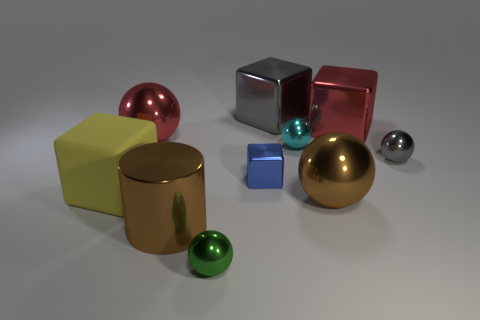Subtract all red balls. How many balls are left? 4 Subtract all large red balls. How many balls are left? 4 Subtract all blue balls. Subtract all brown blocks. How many balls are left? 5 Subtract all blocks. How many objects are left? 6 Add 6 green metal spheres. How many green metal spheres exist? 7 Subtract 0 blue balls. How many objects are left? 10 Subtract all tiny metal cylinders. Subtract all gray shiny things. How many objects are left? 8 Add 3 brown metal balls. How many brown metal balls are left? 4 